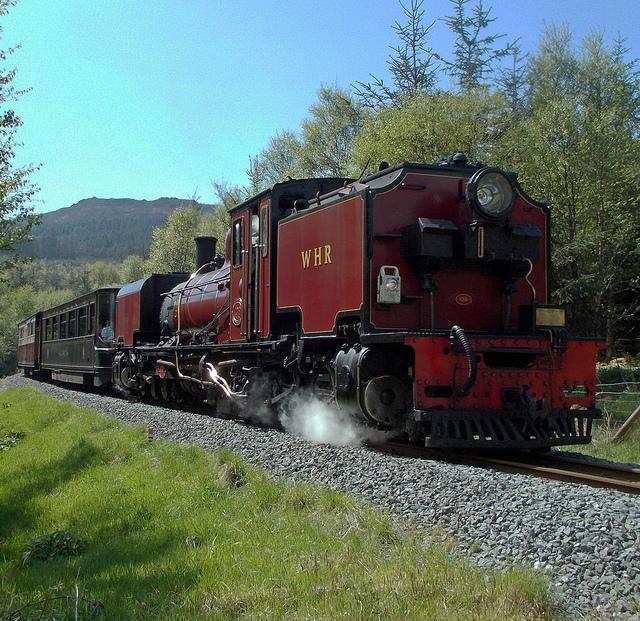Is this train moving?
Keep it brief. Yes. How many tracks are seen?
Short answer required. 1. What are the letters on the train engine?
Be succinct. Whr. What color is the train engine?
Give a very brief answer. Red. What is under the train?
Be succinct. Tracks. What color is the train?
Give a very brief answer. Red. What is the name of the engine?
Short answer required. Whr. 